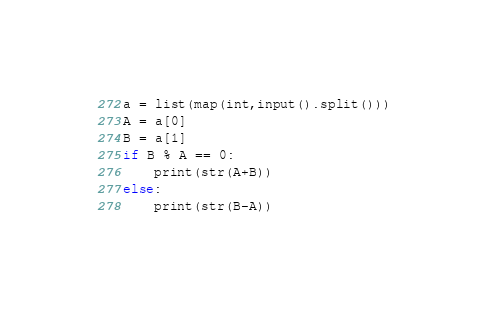Convert code to text. <code><loc_0><loc_0><loc_500><loc_500><_Python_>a = list(map(int,input().split()))
A = a[0]
B = a[1]
if B % A == 0:
    print(str(A+B))
else:
    print(str(B-A))</code> 